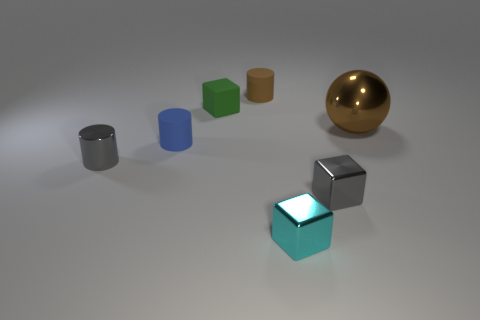Subtract all metallic blocks. How many blocks are left? 1 Subtract 1 cylinders. How many cylinders are left? 2 Subtract all brown blocks. Subtract all red cylinders. How many blocks are left? 3 Add 1 blue things. How many objects exist? 8 Subtract all cylinders. How many objects are left? 4 Subtract 0 blue cubes. How many objects are left? 7 Subtract all large shiny balls. Subtract all gray shiny cylinders. How many objects are left? 5 Add 7 green blocks. How many green blocks are left? 8 Add 3 blocks. How many blocks exist? 6 